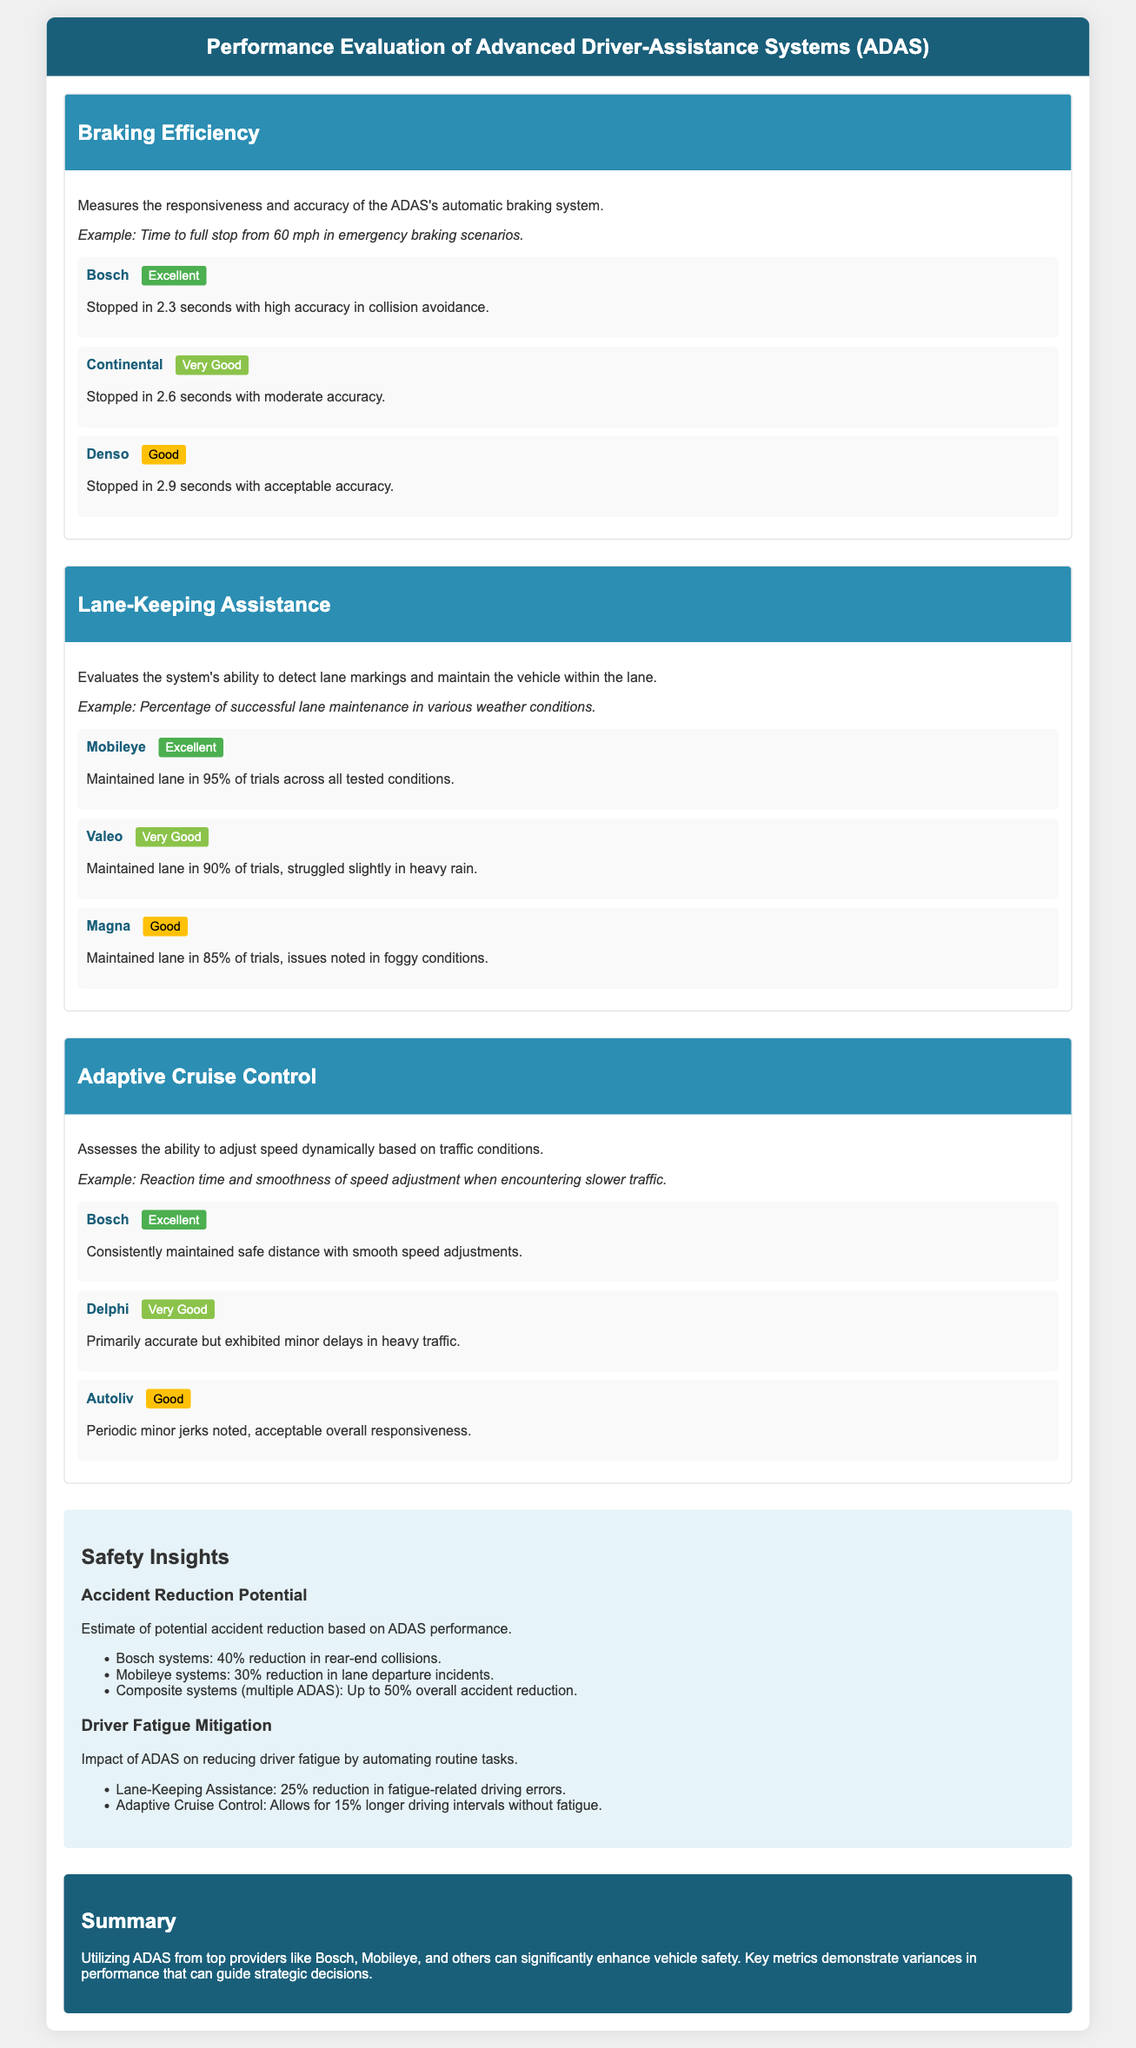What is the performance rating of Bosch in Braking Efficiency? Bosch is rated as "Excellent" in Braking Efficiency according to the document.
Answer: Excellent What percentage of trials did Mobileye successfully maintain lanes? Mobileye maintained lanes in 95% of trials, as detailed in the scorecard.
Answer: 95% What potential accident reduction percentage is attributed to Bosch systems? The document states that Bosch systems can reduce rear-end collisions by 40%.
Answer: 40% How does Adaptive Cruise Control impact driver fatigue according to the insights? The Adaptive Cruise Control allows for a 15% longer driving interval without fatigue, per the safety insights.
Answer: 15% What is the response time for Denso in Braking Efficiency? Denso stopped in 2.9 seconds, which is mentioned in the document as part of the metric evaluation.
Answer: 2.9 seconds What is the main purpose of the document? The document evaluates the performance of Advanced Driver-Assistance Systems (ADAS) for safety features within vehicles.
Answer: Performance Evaluation Which system struggled slightly in heavy rain according to the Lane-Keeping Assistance metric? Valeo is noted to have struggled slightly in heavy rain conditions while maintaining lanes.
Answer: Valeo What type of document is this? This document is a scorecard specifically evaluating Advanced Driver-Assistance Systems (ADAS).
Answer: Scorecard 